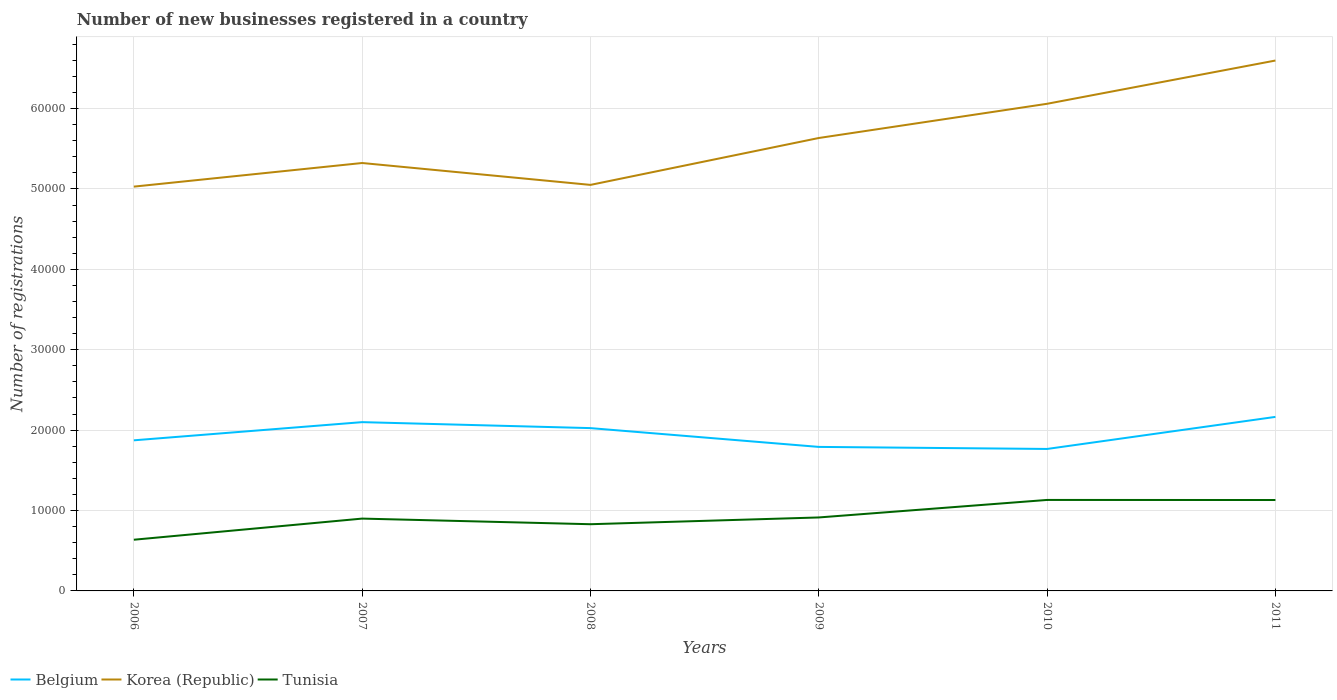Does the line corresponding to Belgium intersect with the line corresponding to Korea (Republic)?
Make the answer very short. No. Is the number of lines equal to the number of legend labels?
Offer a very short reply. Yes. Across all years, what is the maximum number of new businesses registered in Tunisia?
Offer a very short reply. 6368. In which year was the number of new businesses registered in Korea (Republic) maximum?
Give a very brief answer. 2006. What is the total number of new businesses registered in Belgium in the graph?
Make the answer very short. 1074. What is the difference between the highest and the second highest number of new businesses registered in Korea (Republic)?
Make the answer very short. 1.57e+04. What is the difference between the highest and the lowest number of new businesses registered in Tunisia?
Offer a terse response. 2. What is the difference between two consecutive major ticks on the Y-axis?
Offer a terse response. 10000. Are the values on the major ticks of Y-axis written in scientific E-notation?
Keep it short and to the point. No. Does the graph contain grids?
Offer a terse response. Yes. How many legend labels are there?
Offer a terse response. 3. What is the title of the graph?
Provide a succinct answer. Number of new businesses registered in a country. Does "Benin" appear as one of the legend labels in the graph?
Offer a very short reply. No. What is the label or title of the X-axis?
Your answer should be very brief. Years. What is the label or title of the Y-axis?
Ensure brevity in your answer.  Number of registrations. What is the Number of registrations in Belgium in 2006?
Offer a terse response. 1.87e+04. What is the Number of registrations in Korea (Republic) in 2006?
Offer a terse response. 5.03e+04. What is the Number of registrations in Tunisia in 2006?
Ensure brevity in your answer.  6368. What is the Number of registrations in Belgium in 2007?
Give a very brief answer. 2.10e+04. What is the Number of registrations of Korea (Republic) in 2007?
Make the answer very short. 5.32e+04. What is the Number of registrations of Tunisia in 2007?
Your answer should be compact. 8997. What is the Number of registrations of Belgium in 2008?
Your answer should be very brief. 2.03e+04. What is the Number of registrations of Korea (Republic) in 2008?
Provide a short and direct response. 5.05e+04. What is the Number of registrations in Tunisia in 2008?
Keep it short and to the point. 8297. What is the Number of registrations in Belgium in 2009?
Make the answer very short. 1.79e+04. What is the Number of registrations in Korea (Republic) in 2009?
Offer a terse response. 5.63e+04. What is the Number of registrations in Tunisia in 2009?
Your answer should be very brief. 9138. What is the Number of registrations of Belgium in 2010?
Your response must be concise. 1.77e+04. What is the Number of registrations of Korea (Republic) in 2010?
Give a very brief answer. 6.06e+04. What is the Number of registrations of Tunisia in 2010?
Provide a short and direct response. 1.13e+04. What is the Number of registrations of Belgium in 2011?
Your answer should be very brief. 2.16e+04. What is the Number of registrations in Korea (Republic) in 2011?
Give a very brief answer. 6.60e+04. What is the Number of registrations in Tunisia in 2011?
Provide a succinct answer. 1.13e+04. Across all years, what is the maximum Number of registrations of Belgium?
Ensure brevity in your answer.  2.16e+04. Across all years, what is the maximum Number of registrations in Korea (Republic)?
Make the answer very short. 6.60e+04. Across all years, what is the maximum Number of registrations in Tunisia?
Offer a terse response. 1.13e+04. Across all years, what is the minimum Number of registrations in Belgium?
Your response must be concise. 1.77e+04. Across all years, what is the minimum Number of registrations in Korea (Republic)?
Offer a very short reply. 5.03e+04. Across all years, what is the minimum Number of registrations in Tunisia?
Offer a very short reply. 6368. What is the total Number of registrations in Belgium in the graph?
Give a very brief answer. 1.17e+05. What is the total Number of registrations in Korea (Republic) in the graph?
Ensure brevity in your answer.  3.37e+05. What is the total Number of registrations of Tunisia in the graph?
Provide a succinct answer. 5.54e+04. What is the difference between the Number of registrations in Belgium in 2006 and that in 2007?
Your answer should be compact. -2261. What is the difference between the Number of registrations in Korea (Republic) in 2006 and that in 2007?
Provide a short and direct response. -2938. What is the difference between the Number of registrations in Tunisia in 2006 and that in 2007?
Your response must be concise. -2629. What is the difference between the Number of registrations in Belgium in 2006 and that in 2008?
Provide a short and direct response. -1518. What is the difference between the Number of registrations in Korea (Republic) in 2006 and that in 2008?
Make the answer very short. -216. What is the difference between the Number of registrations in Tunisia in 2006 and that in 2008?
Give a very brief answer. -1929. What is the difference between the Number of registrations of Belgium in 2006 and that in 2009?
Ensure brevity in your answer.  820. What is the difference between the Number of registrations of Korea (Republic) in 2006 and that in 2009?
Ensure brevity in your answer.  -6048. What is the difference between the Number of registrations in Tunisia in 2006 and that in 2009?
Offer a very short reply. -2770. What is the difference between the Number of registrations of Belgium in 2006 and that in 2010?
Provide a short and direct response. 1074. What is the difference between the Number of registrations of Korea (Republic) in 2006 and that in 2010?
Make the answer very short. -1.03e+04. What is the difference between the Number of registrations in Tunisia in 2006 and that in 2010?
Your answer should be very brief. -4949. What is the difference between the Number of registrations in Belgium in 2006 and that in 2011?
Your answer should be very brief. -2914. What is the difference between the Number of registrations of Korea (Republic) in 2006 and that in 2011?
Keep it short and to the point. -1.57e+04. What is the difference between the Number of registrations of Tunisia in 2006 and that in 2011?
Provide a succinct answer. -4939. What is the difference between the Number of registrations in Belgium in 2007 and that in 2008?
Your response must be concise. 743. What is the difference between the Number of registrations of Korea (Republic) in 2007 and that in 2008?
Your answer should be very brief. 2722. What is the difference between the Number of registrations of Tunisia in 2007 and that in 2008?
Give a very brief answer. 700. What is the difference between the Number of registrations in Belgium in 2007 and that in 2009?
Your answer should be compact. 3081. What is the difference between the Number of registrations of Korea (Republic) in 2007 and that in 2009?
Provide a short and direct response. -3110. What is the difference between the Number of registrations of Tunisia in 2007 and that in 2009?
Ensure brevity in your answer.  -141. What is the difference between the Number of registrations of Belgium in 2007 and that in 2010?
Offer a terse response. 3335. What is the difference between the Number of registrations of Korea (Republic) in 2007 and that in 2010?
Your answer should be compact. -7366. What is the difference between the Number of registrations of Tunisia in 2007 and that in 2010?
Provide a short and direct response. -2320. What is the difference between the Number of registrations of Belgium in 2007 and that in 2011?
Your answer should be very brief. -653. What is the difference between the Number of registrations in Korea (Republic) in 2007 and that in 2011?
Offer a terse response. -1.27e+04. What is the difference between the Number of registrations in Tunisia in 2007 and that in 2011?
Your answer should be very brief. -2310. What is the difference between the Number of registrations in Belgium in 2008 and that in 2009?
Make the answer very short. 2338. What is the difference between the Number of registrations of Korea (Republic) in 2008 and that in 2009?
Give a very brief answer. -5832. What is the difference between the Number of registrations in Tunisia in 2008 and that in 2009?
Keep it short and to the point. -841. What is the difference between the Number of registrations in Belgium in 2008 and that in 2010?
Offer a very short reply. 2592. What is the difference between the Number of registrations of Korea (Republic) in 2008 and that in 2010?
Your response must be concise. -1.01e+04. What is the difference between the Number of registrations of Tunisia in 2008 and that in 2010?
Provide a succinct answer. -3020. What is the difference between the Number of registrations of Belgium in 2008 and that in 2011?
Keep it short and to the point. -1396. What is the difference between the Number of registrations in Korea (Republic) in 2008 and that in 2011?
Your answer should be compact. -1.55e+04. What is the difference between the Number of registrations of Tunisia in 2008 and that in 2011?
Make the answer very short. -3010. What is the difference between the Number of registrations in Belgium in 2009 and that in 2010?
Offer a very short reply. 254. What is the difference between the Number of registrations in Korea (Republic) in 2009 and that in 2010?
Offer a terse response. -4256. What is the difference between the Number of registrations of Tunisia in 2009 and that in 2010?
Provide a short and direct response. -2179. What is the difference between the Number of registrations in Belgium in 2009 and that in 2011?
Offer a terse response. -3734. What is the difference between the Number of registrations in Korea (Republic) in 2009 and that in 2011?
Offer a very short reply. -9636. What is the difference between the Number of registrations of Tunisia in 2009 and that in 2011?
Your answer should be very brief. -2169. What is the difference between the Number of registrations in Belgium in 2010 and that in 2011?
Ensure brevity in your answer.  -3988. What is the difference between the Number of registrations of Korea (Republic) in 2010 and that in 2011?
Your response must be concise. -5380. What is the difference between the Number of registrations in Tunisia in 2010 and that in 2011?
Provide a succinct answer. 10. What is the difference between the Number of registrations in Belgium in 2006 and the Number of registrations in Korea (Republic) in 2007?
Provide a short and direct response. -3.45e+04. What is the difference between the Number of registrations in Belgium in 2006 and the Number of registrations in Tunisia in 2007?
Your response must be concise. 9736. What is the difference between the Number of registrations of Korea (Republic) in 2006 and the Number of registrations of Tunisia in 2007?
Provide a succinct answer. 4.13e+04. What is the difference between the Number of registrations in Belgium in 2006 and the Number of registrations in Korea (Republic) in 2008?
Your answer should be compact. -3.18e+04. What is the difference between the Number of registrations of Belgium in 2006 and the Number of registrations of Tunisia in 2008?
Your answer should be compact. 1.04e+04. What is the difference between the Number of registrations of Korea (Republic) in 2006 and the Number of registrations of Tunisia in 2008?
Make the answer very short. 4.20e+04. What is the difference between the Number of registrations in Belgium in 2006 and the Number of registrations in Korea (Republic) in 2009?
Ensure brevity in your answer.  -3.76e+04. What is the difference between the Number of registrations in Belgium in 2006 and the Number of registrations in Tunisia in 2009?
Make the answer very short. 9595. What is the difference between the Number of registrations of Korea (Republic) in 2006 and the Number of registrations of Tunisia in 2009?
Provide a short and direct response. 4.12e+04. What is the difference between the Number of registrations in Belgium in 2006 and the Number of registrations in Korea (Republic) in 2010?
Make the answer very short. -4.19e+04. What is the difference between the Number of registrations of Belgium in 2006 and the Number of registrations of Tunisia in 2010?
Provide a succinct answer. 7416. What is the difference between the Number of registrations in Korea (Republic) in 2006 and the Number of registrations in Tunisia in 2010?
Give a very brief answer. 3.90e+04. What is the difference between the Number of registrations of Belgium in 2006 and the Number of registrations of Korea (Republic) in 2011?
Give a very brief answer. -4.72e+04. What is the difference between the Number of registrations of Belgium in 2006 and the Number of registrations of Tunisia in 2011?
Give a very brief answer. 7426. What is the difference between the Number of registrations in Korea (Republic) in 2006 and the Number of registrations in Tunisia in 2011?
Keep it short and to the point. 3.90e+04. What is the difference between the Number of registrations in Belgium in 2007 and the Number of registrations in Korea (Republic) in 2008?
Offer a very short reply. -2.95e+04. What is the difference between the Number of registrations in Belgium in 2007 and the Number of registrations in Tunisia in 2008?
Provide a short and direct response. 1.27e+04. What is the difference between the Number of registrations of Korea (Republic) in 2007 and the Number of registrations of Tunisia in 2008?
Keep it short and to the point. 4.49e+04. What is the difference between the Number of registrations in Belgium in 2007 and the Number of registrations in Korea (Republic) in 2009?
Provide a short and direct response. -3.53e+04. What is the difference between the Number of registrations of Belgium in 2007 and the Number of registrations of Tunisia in 2009?
Ensure brevity in your answer.  1.19e+04. What is the difference between the Number of registrations of Korea (Republic) in 2007 and the Number of registrations of Tunisia in 2009?
Ensure brevity in your answer.  4.41e+04. What is the difference between the Number of registrations of Belgium in 2007 and the Number of registrations of Korea (Republic) in 2010?
Offer a terse response. -3.96e+04. What is the difference between the Number of registrations of Belgium in 2007 and the Number of registrations of Tunisia in 2010?
Give a very brief answer. 9677. What is the difference between the Number of registrations of Korea (Republic) in 2007 and the Number of registrations of Tunisia in 2010?
Provide a succinct answer. 4.19e+04. What is the difference between the Number of registrations in Belgium in 2007 and the Number of registrations in Korea (Republic) in 2011?
Offer a very short reply. -4.50e+04. What is the difference between the Number of registrations of Belgium in 2007 and the Number of registrations of Tunisia in 2011?
Give a very brief answer. 9687. What is the difference between the Number of registrations of Korea (Republic) in 2007 and the Number of registrations of Tunisia in 2011?
Provide a succinct answer. 4.19e+04. What is the difference between the Number of registrations in Belgium in 2008 and the Number of registrations in Korea (Republic) in 2009?
Ensure brevity in your answer.  -3.61e+04. What is the difference between the Number of registrations in Belgium in 2008 and the Number of registrations in Tunisia in 2009?
Your answer should be compact. 1.11e+04. What is the difference between the Number of registrations in Korea (Republic) in 2008 and the Number of registrations in Tunisia in 2009?
Make the answer very short. 4.14e+04. What is the difference between the Number of registrations in Belgium in 2008 and the Number of registrations in Korea (Republic) in 2010?
Provide a short and direct response. -4.03e+04. What is the difference between the Number of registrations of Belgium in 2008 and the Number of registrations of Tunisia in 2010?
Provide a short and direct response. 8934. What is the difference between the Number of registrations in Korea (Republic) in 2008 and the Number of registrations in Tunisia in 2010?
Your answer should be compact. 3.92e+04. What is the difference between the Number of registrations of Belgium in 2008 and the Number of registrations of Korea (Republic) in 2011?
Your answer should be very brief. -4.57e+04. What is the difference between the Number of registrations in Belgium in 2008 and the Number of registrations in Tunisia in 2011?
Make the answer very short. 8944. What is the difference between the Number of registrations in Korea (Republic) in 2008 and the Number of registrations in Tunisia in 2011?
Provide a short and direct response. 3.92e+04. What is the difference between the Number of registrations of Belgium in 2009 and the Number of registrations of Korea (Republic) in 2010?
Give a very brief answer. -4.27e+04. What is the difference between the Number of registrations in Belgium in 2009 and the Number of registrations in Tunisia in 2010?
Your answer should be compact. 6596. What is the difference between the Number of registrations of Korea (Republic) in 2009 and the Number of registrations of Tunisia in 2010?
Your answer should be very brief. 4.50e+04. What is the difference between the Number of registrations in Belgium in 2009 and the Number of registrations in Korea (Republic) in 2011?
Provide a short and direct response. -4.81e+04. What is the difference between the Number of registrations in Belgium in 2009 and the Number of registrations in Tunisia in 2011?
Make the answer very short. 6606. What is the difference between the Number of registrations of Korea (Republic) in 2009 and the Number of registrations of Tunisia in 2011?
Provide a short and direct response. 4.50e+04. What is the difference between the Number of registrations in Belgium in 2010 and the Number of registrations in Korea (Republic) in 2011?
Keep it short and to the point. -4.83e+04. What is the difference between the Number of registrations of Belgium in 2010 and the Number of registrations of Tunisia in 2011?
Ensure brevity in your answer.  6352. What is the difference between the Number of registrations of Korea (Republic) in 2010 and the Number of registrations of Tunisia in 2011?
Offer a terse response. 4.93e+04. What is the average Number of registrations in Belgium per year?
Offer a terse response. 1.95e+04. What is the average Number of registrations in Korea (Republic) per year?
Keep it short and to the point. 5.62e+04. What is the average Number of registrations of Tunisia per year?
Provide a short and direct response. 9237.33. In the year 2006, what is the difference between the Number of registrations of Belgium and Number of registrations of Korea (Republic)?
Ensure brevity in your answer.  -3.16e+04. In the year 2006, what is the difference between the Number of registrations of Belgium and Number of registrations of Tunisia?
Your answer should be compact. 1.24e+04. In the year 2006, what is the difference between the Number of registrations of Korea (Republic) and Number of registrations of Tunisia?
Your answer should be compact. 4.39e+04. In the year 2007, what is the difference between the Number of registrations of Belgium and Number of registrations of Korea (Republic)?
Ensure brevity in your answer.  -3.22e+04. In the year 2007, what is the difference between the Number of registrations in Belgium and Number of registrations in Tunisia?
Offer a terse response. 1.20e+04. In the year 2007, what is the difference between the Number of registrations of Korea (Republic) and Number of registrations of Tunisia?
Offer a very short reply. 4.42e+04. In the year 2008, what is the difference between the Number of registrations in Belgium and Number of registrations in Korea (Republic)?
Give a very brief answer. -3.03e+04. In the year 2008, what is the difference between the Number of registrations of Belgium and Number of registrations of Tunisia?
Provide a short and direct response. 1.20e+04. In the year 2008, what is the difference between the Number of registrations in Korea (Republic) and Number of registrations in Tunisia?
Provide a short and direct response. 4.22e+04. In the year 2009, what is the difference between the Number of registrations of Belgium and Number of registrations of Korea (Republic)?
Ensure brevity in your answer.  -3.84e+04. In the year 2009, what is the difference between the Number of registrations of Belgium and Number of registrations of Tunisia?
Your answer should be compact. 8775. In the year 2009, what is the difference between the Number of registrations in Korea (Republic) and Number of registrations in Tunisia?
Make the answer very short. 4.72e+04. In the year 2010, what is the difference between the Number of registrations in Belgium and Number of registrations in Korea (Republic)?
Your answer should be very brief. -4.29e+04. In the year 2010, what is the difference between the Number of registrations of Belgium and Number of registrations of Tunisia?
Your response must be concise. 6342. In the year 2010, what is the difference between the Number of registrations of Korea (Republic) and Number of registrations of Tunisia?
Ensure brevity in your answer.  4.93e+04. In the year 2011, what is the difference between the Number of registrations in Belgium and Number of registrations in Korea (Republic)?
Offer a very short reply. -4.43e+04. In the year 2011, what is the difference between the Number of registrations of Belgium and Number of registrations of Tunisia?
Provide a succinct answer. 1.03e+04. In the year 2011, what is the difference between the Number of registrations in Korea (Republic) and Number of registrations in Tunisia?
Make the answer very short. 5.47e+04. What is the ratio of the Number of registrations in Belgium in 2006 to that in 2007?
Your answer should be compact. 0.89. What is the ratio of the Number of registrations in Korea (Republic) in 2006 to that in 2007?
Your answer should be very brief. 0.94. What is the ratio of the Number of registrations of Tunisia in 2006 to that in 2007?
Your response must be concise. 0.71. What is the ratio of the Number of registrations of Belgium in 2006 to that in 2008?
Make the answer very short. 0.93. What is the ratio of the Number of registrations of Korea (Republic) in 2006 to that in 2008?
Your answer should be very brief. 1. What is the ratio of the Number of registrations of Tunisia in 2006 to that in 2008?
Provide a short and direct response. 0.77. What is the ratio of the Number of registrations of Belgium in 2006 to that in 2009?
Keep it short and to the point. 1.05. What is the ratio of the Number of registrations in Korea (Republic) in 2006 to that in 2009?
Keep it short and to the point. 0.89. What is the ratio of the Number of registrations in Tunisia in 2006 to that in 2009?
Make the answer very short. 0.7. What is the ratio of the Number of registrations in Belgium in 2006 to that in 2010?
Keep it short and to the point. 1.06. What is the ratio of the Number of registrations of Korea (Republic) in 2006 to that in 2010?
Keep it short and to the point. 0.83. What is the ratio of the Number of registrations of Tunisia in 2006 to that in 2010?
Give a very brief answer. 0.56. What is the ratio of the Number of registrations in Belgium in 2006 to that in 2011?
Your answer should be compact. 0.87. What is the ratio of the Number of registrations in Korea (Republic) in 2006 to that in 2011?
Offer a very short reply. 0.76. What is the ratio of the Number of registrations of Tunisia in 2006 to that in 2011?
Give a very brief answer. 0.56. What is the ratio of the Number of registrations in Belgium in 2007 to that in 2008?
Offer a terse response. 1.04. What is the ratio of the Number of registrations of Korea (Republic) in 2007 to that in 2008?
Ensure brevity in your answer.  1.05. What is the ratio of the Number of registrations in Tunisia in 2007 to that in 2008?
Keep it short and to the point. 1.08. What is the ratio of the Number of registrations in Belgium in 2007 to that in 2009?
Ensure brevity in your answer.  1.17. What is the ratio of the Number of registrations of Korea (Republic) in 2007 to that in 2009?
Ensure brevity in your answer.  0.94. What is the ratio of the Number of registrations in Tunisia in 2007 to that in 2009?
Your answer should be compact. 0.98. What is the ratio of the Number of registrations in Belgium in 2007 to that in 2010?
Your response must be concise. 1.19. What is the ratio of the Number of registrations of Korea (Republic) in 2007 to that in 2010?
Offer a very short reply. 0.88. What is the ratio of the Number of registrations of Tunisia in 2007 to that in 2010?
Ensure brevity in your answer.  0.8. What is the ratio of the Number of registrations in Belgium in 2007 to that in 2011?
Offer a very short reply. 0.97. What is the ratio of the Number of registrations of Korea (Republic) in 2007 to that in 2011?
Offer a very short reply. 0.81. What is the ratio of the Number of registrations in Tunisia in 2007 to that in 2011?
Offer a terse response. 0.8. What is the ratio of the Number of registrations in Belgium in 2008 to that in 2009?
Offer a very short reply. 1.13. What is the ratio of the Number of registrations of Korea (Republic) in 2008 to that in 2009?
Offer a terse response. 0.9. What is the ratio of the Number of registrations of Tunisia in 2008 to that in 2009?
Provide a short and direct response. 0.91. What is the ratio of the Number of registrations of Belgium in 2008 to that in 2010?
Your answer should be compact. 1.15. What is the ratio of the Number of registrations in Korea (Republic) in 2008 to that in 2010?
Your answer should be very brief. 0.83. What is the ratio of the Number of registrations in Tunisia in 2008 to that in 2010?
Offer a very short reply. 0.73. What is the ratio of the Number of registrations in Belgium in 2008 to that in 2011?
Your answer should be very brief. 0.94. What is the ratio of the Number of registrations in Korea (Republic) in 2008 to that in 2011?
Give a very brief answer. 0.77. What is the ratio of the Number of registrations of Tunisia in 2008 to that in 2011?
Offer a very short reply. 0.73. What is the ratio of the Number of registrations in Belgium in 2009 to that in 2010?
Keep it short and to the point. 1.01. What is the ratio of the Number of registrations in Korea (Republic) in 2009 to that in 2010?
Your answer should be compact. 0.93. What is the ratio of the Number of registrations in Tunisia in 2009 to that in 2010?
Offer a very short reply. 0.81. What is the ratio of the Number of registrations in Belgium in 2009 to that in 2011?
Your answer should be compact. 0.83. What is the ratio of the Number of registrations of Korea (Republic) in 2009 to that in 2011?
Provide a succinct answer. 0.85. What is the ratio of the Number of registrations in Tunisia in 2009 to that in 2011?
Your answer should be very brief. 0.81. What is the ratio of the Number of registrations in Belgium in 2010 to that in 2011?
Offer a very short reply. 0.82. What is the ratio of the Number of registrations of Korea (Republic) in 2010 to that in 2011?
Provide a succinct answer. 0.92. What is the difference between the highest and the second highest Number of registrations in Belgium?
Your answer should be very brief. 653. What is the difference between the highest and the second highest Number of registrations in Korea (Republic)?
Your response must be concise. 5380. What is the difference between the highest and the lowest Number of registrations in Belgium?
Offer a very short reply. 3988. What is the difference between the highest and the lowest Number of registrations of Korea (Republic)?
Provide a succinct answer. 1.57e+04. What is the difference between the highest and the lowest Number of registrations of Tunisia?
Make the answer very short. 4949. 